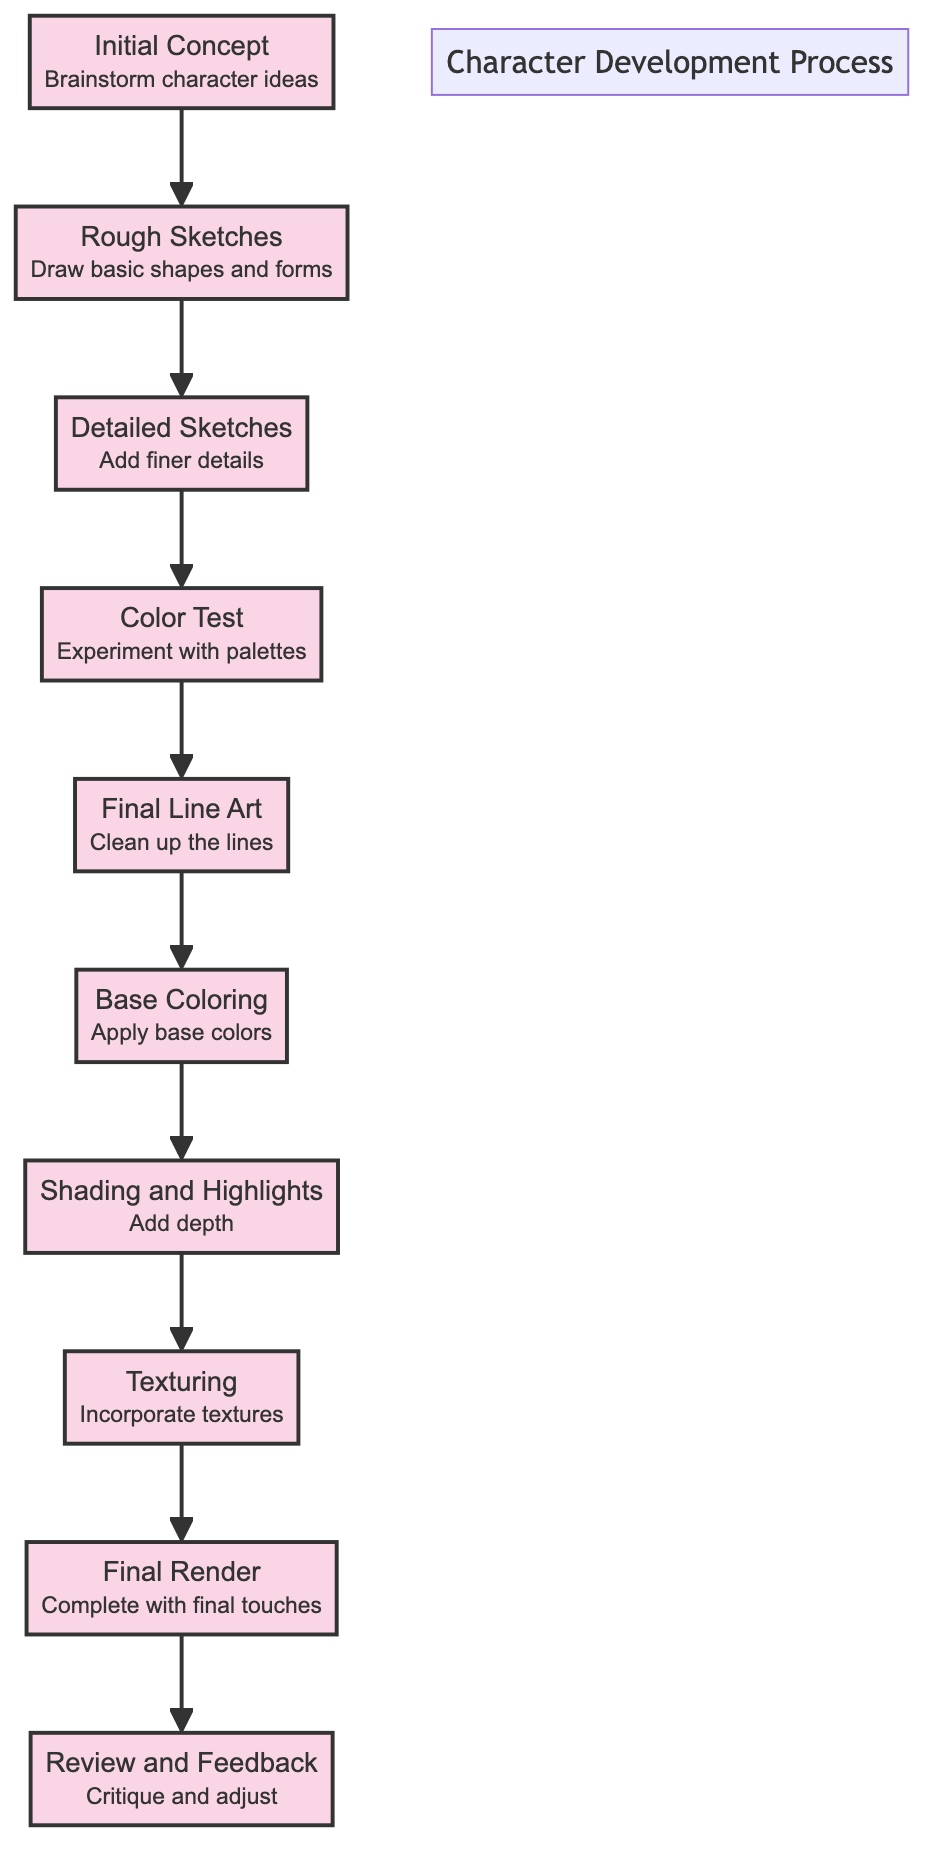What's the third step in the character development process? The third step is "Detailed Sketches," which follows "Rough Sketches" and precedes "Color Test."
Answer: Detailed Sketches How many steps are there in the character development process? Counting all the steps from "Initial Concept" to "Review and Feedback," there are a total of 10 steps.
Answer: 10 What step comes after "Base Coloring"? "Shading and Highlights" is the immediate next step in the sequence after "Base Coloring."
Answer: Shading and Highlights Which step focuses on experimenting with colors? "Color Test" is specifically where the focus is on experimenting with different color palettes for the character.
Answer: Color Test What are the two steps that precede the "Final Render"? The two steps before "Final Render" are "Texturing" and "Shading and Highlights." Both are required to prepare for the final completion.
Answer: Texturing and Shading and Highlights Explain the relationship between "Initial Concept" and "Review and Feedback." "Initial Concept" is the starting point, and after several development steps—including sketches, coloring, and texturing—the process culminates at "Review and Feedback," where the character design is critiqued and adjustments are made.
Answer: Review and Feedback In which steps are textures incorporated into the design? The "Texturing" step is where textures are specifically added to enhance the character's appearance, following the addition of depth in the "Shading and Highlights" step.
Answer: Texturing What does the "Final Line Art" step focus on? In "Final Line Art," the focus is on cleaning up the lines of the character sketches to provide a polished look before coloring begins.
Answer: Clean up the lines 